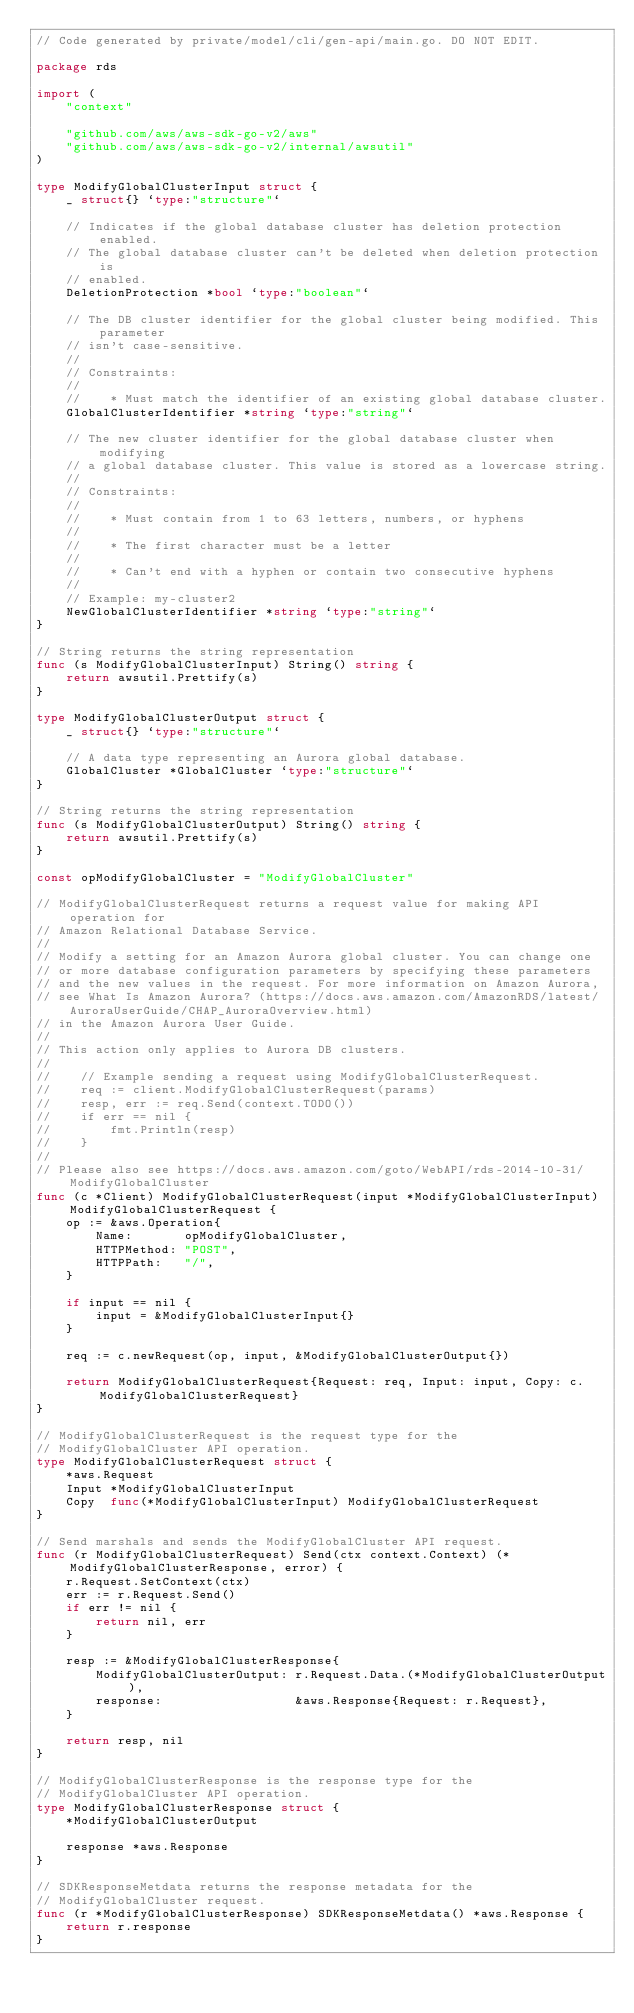Convert code to text. <code><loc_0><loc_0><loc_500><loc_500><_Go_>// Code generated by private/model/cli/gen-api/main.go. DO NOT EDIT.

package rds

import (
	"context"

	"github.com/aws/aws-sdk-go-v2/aws"
	"github.com/aws/aws-sdk-go-v2/internal/awsutil"
)

type ModifyGlobalClusterInput struct {
	_ struct{} `type:"structure"`

	// Indicates if the global database cluster has deletion protection enabled.
	// The global database cluster can't be deleted when deletion protection is
	// enabled.
	DeletionProtection *bool `type:"boolean"`

	// The DB cluster identifier for the global cluster being modified. This parameter
	// isn't case-sensitive.
	//
	// Constraints:
	//
	//    * Must match the identifier of an existing global database cluster.
	GlobalClusterIdentifier *string `type:"string"`

	// The new cluster identifier for the global database cluster when modifying
	// a global database cluster. This value is stored as a lowercase string.
	//
	// Constraints:
	//
	//    * Must contain from 1 to 63 letters, numbers, or hyphens
	//
	//    * The first character must be a letter
	//
	//    * Can't end with a hyphen or contain two consecutive hyphens
	//
	// Example: my-cluster2
	NewGlobalClusterIdentifier *string `type:"string"`
}

// String returns the string representation
func (s ModifyGlobalClusterInput) String() string {
	return awsutil.Prettify(s)
}

type ModifyGlobalClusterOutput struct {
	_ struct{} `type:"structure"`

	// A data type representing an Aurora global database.
	GlobalCluster *GlobalCluster `type:"structure"`
}

// String returns the string representation
func (s ModifyGlobalClusterOutput) String() string {
	return awsutil.Prettify(s)
}

const opModifyGlobalCluster = "ModifyGlobalCluster"

// ModifyGlobalClusterRequest returns a request value for making API operation for
// Amazon Relational Database Service.
//
// Modify a setting for an Amazon Aurora global cluster. You can change one
// or more database configuration parameters by specifying these parameters
// and the new values in the request. For more information on Amazon Aurora,
// see What Is Amazon Aurora? (https://docs.aws.amazon.com/AmazonRDS/latest/AuroraUserGuide/CHAP_AuroraOverview.html)
// in the Amazon Aurora User Guide.
//
// This action only applies to Aurora DB clusters.
//
//    // Example sending a request using ModifyGlobalClusterRequest.
//    req := client.ModifyGlobalClusterRequest(params)
//    resp, err := req.Send(context.TODO())
//    if err == nil {
//        fmt.Println(resp)
//    }
//
// Please also see https://docs.aws.amazon.com/goto/WebAPI/rds-2014-10-31/ModifyGlobalCluster
func (c *Client) ModifyGlobalClusterRequest(input *ModifyGlobalClusterInput) ModifyGlobalClusterRequest {
	op := &aws.Operation{
		Name:       opModifyGlobalCluster,
		HTTPMethod: "POST",
		HTTPPath:   "/",
	}

	if input == nil {
		input = &ModifyGlobalClusterInput{}
	}

	req := c.newRequest(op, input, &ModifyGlobalClusterOutput{})

	return ModifyGlobalClusterRequest{Request: req, Input: input, Copy: c.ModifyGlobalClusterRequest}
}

// ModifyGlobalClusterRequest is the request type for the
// ModifyGlobalCluster API operation.
type ModifyGlobalClusterRequest struct {
	*aws.Request
	Input *ModifyGlobalClusterInput
	Copy  func(*ModifyGlobalClusterInput) ModifyGlobalClusterRequest
}

// Send marshals and sends the ModifyGlobalCluster API request.
func (r ModifyGlobalClusterRequest) Send(ctx context.Context) (*ModifyGlobalClusterResponse, error) {
	r.Request.SetContext(ctx)
	err := r.Request.Send()
	if err != nil {
		return nil, err
	}

	resp := &ModifyGlobalClusterResponse{
		ModifyGlobalClusterOutput: r.Request.Data.(*ModifyGlobalClusterOutput),
		response:                  &aws.Response{Request: r.Request},
	}

	return resp, nil
}

// ModifyGlobalClusterResponse is the response type for the
// ModifyGlobalCluster API operation.
type ModifyGlobalClusterResponse struct {
	*ModifyGlobalClusterOutput

	response *aws.Response
}

// SDKResponseMetdata returns the response metadata for the
// ModifyGlobalCluster request.
func (r *ModifyGlobalClusterResponse) SDKResponseMetdata() *aws.Response {
	return r.response
}
</code> 